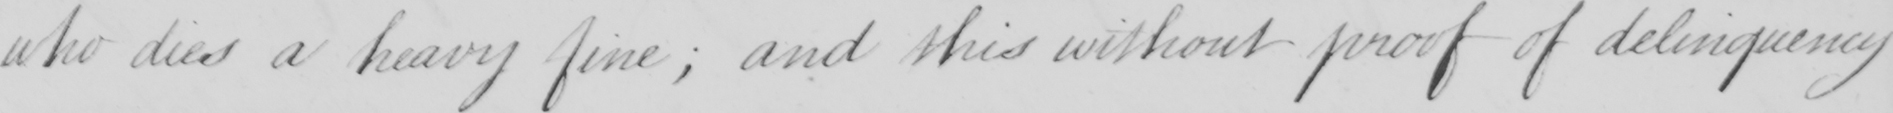What does this handwritten line say? who dies a heavy fine  ; and this without proof of deliquency 